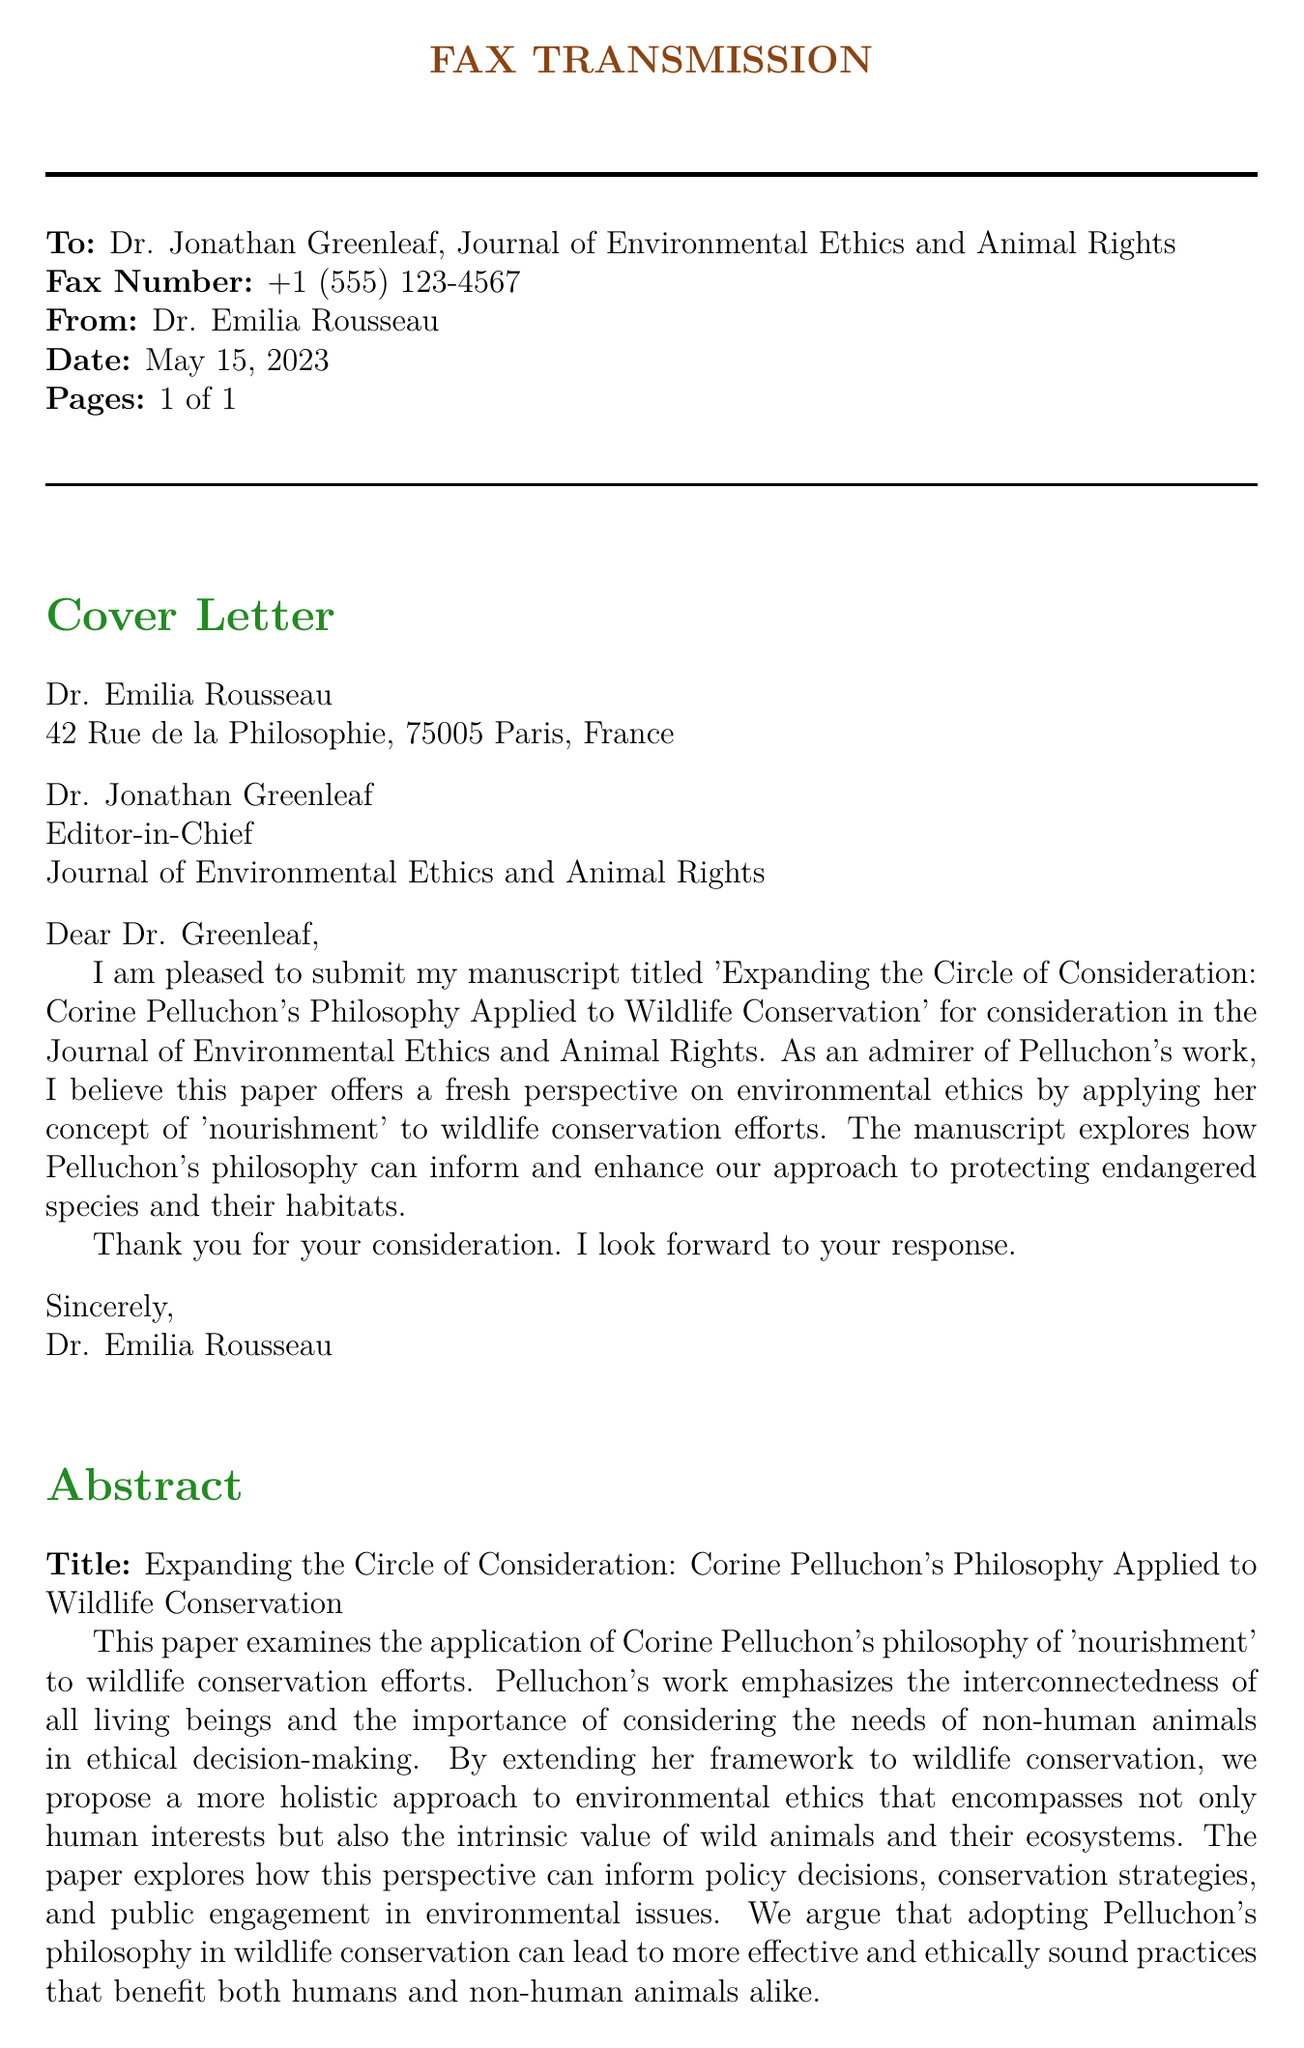What is the title of the manuscript? The title of the manuscript is explicitly stated in the abstract section of the document.
Answer: Expanding the Circle of Consideration: Corine Pelluchon's Philosophy Applied to Wildlife Conservation Who is the author of the manuscript? The author is mentioned in the cover letter and also at the top of the document.
Answer: Dr. Emilia Rousseau When was the fax sent? The date is provided prominently in the document.
Answer: May 15, 2023 Who is the editor receiving the submission? The editor's name is listed in the cover letter.
Answer: Dr. Jonathan Greenleaf What is the main focus of the paper according to the abstract? The main focus is described in the abstract, emphasizing a specific ethical philosophy.
Answer: Application of Corine Pelluchon's philosophy to wildlife conservation How many pages is the fax? The total page count is mentioned in the fax header.
Answer: 1 of 1 What type of document is this? The structure and content indicate that it is a particular form of academic communication.
Answer: Faxed manuscript submission What concept does the paper apply to wildlife conservation? The concept discussed in the paper is a key philosophical term referenced throughout.
Answer: Nourishment What does the author argue regarding conservation practices? The manuscript makes a claim about the relationship between philosophy and conservation effectiveness.
Answer: More effective and ethically sound practices 